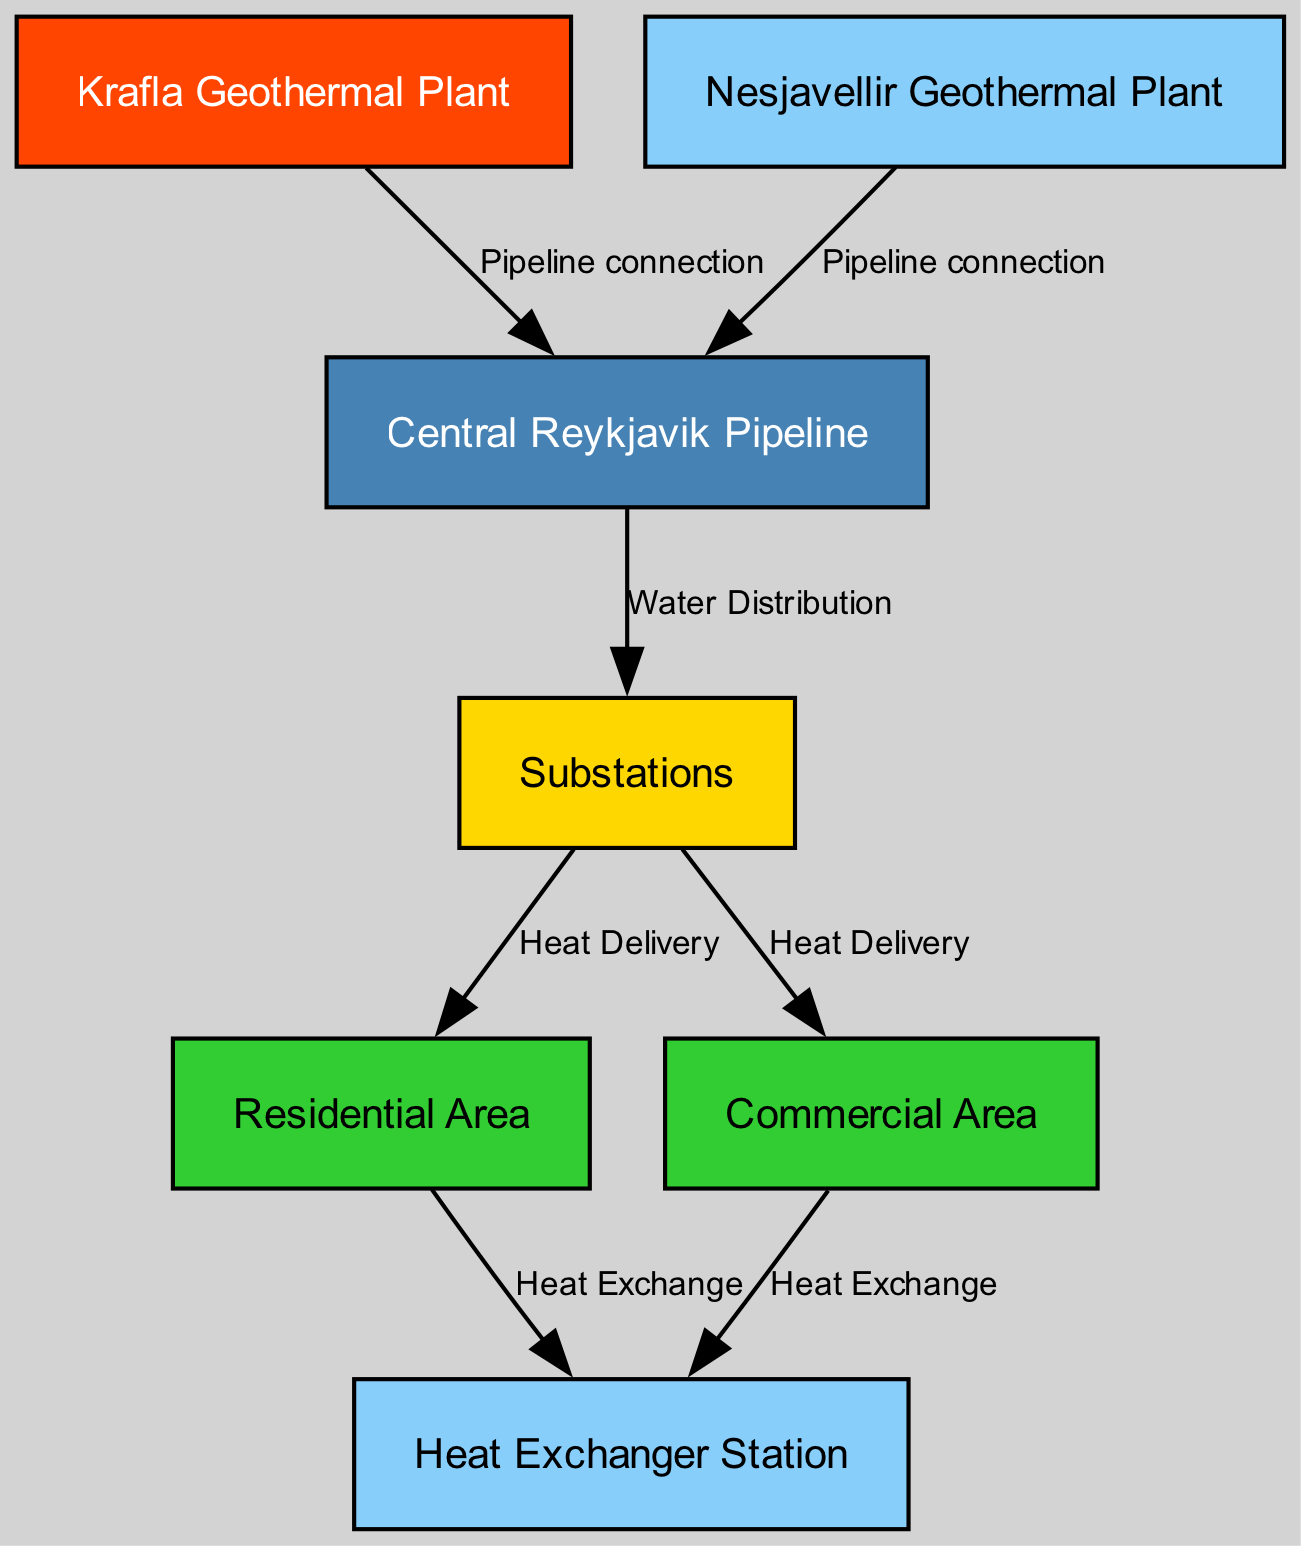What is the primary geothermal energy source in Reykjavik's heating network? The diagram identifies "Krafla Geothermal Plant" as the primary geothermal energy source for the heating network in Reykjavik.
Answer: Krafla Geothermal Plant How many nodes are there in the diagram? The nodes present in the diagram include: Krafla Geothermal Plant, Nesjavellir Geothermal Plant, Central Reykjavik Pipeline, Substations, Residential Area, Commercial Area, and Heat Exchanger Station, totaling seven nodes.
Answer: 7 What kind of connection does the Central Reykjavik Pipeline have? The diagram shows that the Central Reykjavik Pipeline has connections labeled as "Pipeline connection" with both the Krafla Geothermal Plant and the Nesjavellir Geothermal Plant.
Answer: Pipeline connection Which area receives regulated heat delivery from substations? According to the diagram, both the "Residential Area" and "Commercial Area" receive regulated heat delivery from the substations.
Answer: Residential Area, Commercial Area What is the purpose of the heat exchanger station? The heat exchanger station is used for "Heat Exchange," which facilitates the heat transfer for efficient use, as indicated in the diagram.
Answer: Heat Exchange How many major geothermal energy sources are indicated in the diagram? The diagram includes two major geothermal energy sources: the Krafla Geothermal Plant and the Nesjavellir Geothermal Plant, as noted in the node descriptions.
Answer: 2 What processes occur from the substations to the end users? From the substations, the processes outlined are "Heat Delivery" to both the Residential Area and Commercial Area, reflecting the distribution of heat.
Answer: Heat Delivery Which nodes are categorized under heat exchange? The diagram designates both the Residential Area and the Commercial Area as nodes that engage in "Heat Exchange" with the heat exchanger station.
Answer: Residential Area, Commercial Area Which nodes directly connect to the Central Reykjavik Pipeline? The nodes that directly connect to the Central Reykjavik Pipeline are the Krafla Geothermal Plant and the Nesjavellir Geothermal Power Plant, which provide heated water through pipeline connections.
Answer: Krafla Geothermal Plant, Nesjavellir Geothermal Power Plant 